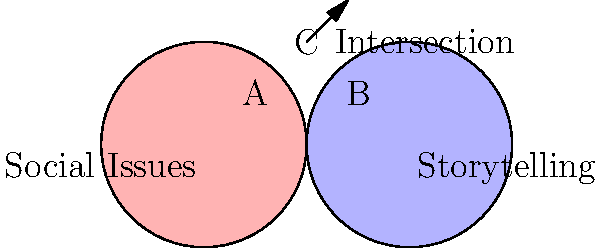In the Venn diagram above, which area represents stories that effectively address social issues while also maintaining compelling narrative structures? To answer this question, let's analyze the Venn diagram step-by-step:

1. The left circle (in pink) represents "Social Issues."
2. The right circle (in blue) represents "Storytelling."
3. The overlapping area in the middle, labeled "C," represents the intersection of these two concepts.

The intersection (area C) is where social issues and storytelling come together. This area represents:

a) Stories that effectively address social issues: These narratives tackle important societal problems, giving voice to marginalized communities and raising awareness about critical issues.

b) Stories that maintain compelling narrative structures: These are well-crafted tales that engage the audience through strong plot development, character arcs, and thematic depth.

The intersection, therefore, represents stories that successfully balance both aspects: they address important social issues while also being engaging and well-structured narratives. This is the sweet spot for an actress dedicated to bringing marginalized voices to the forefront of storytelling, as it allows for impactful messaging without sacrificing the art of storytelling.
Answer: C (The intersection) 